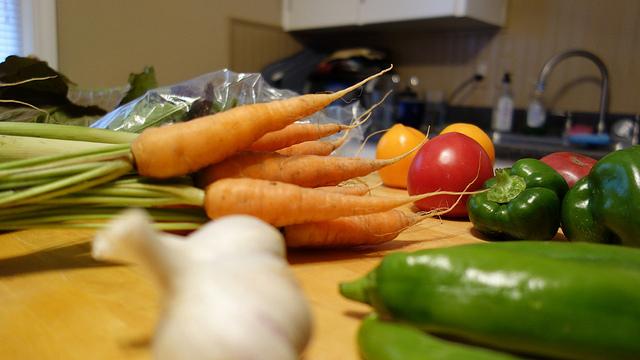What room is this?
Give a very brief answer. Kitchen. What kind of vegetables are shown?
Give a very brief answer. Carrots bell peppers squash. What kind of vegetables are the color orange?
Concise answer only. Carrots. 